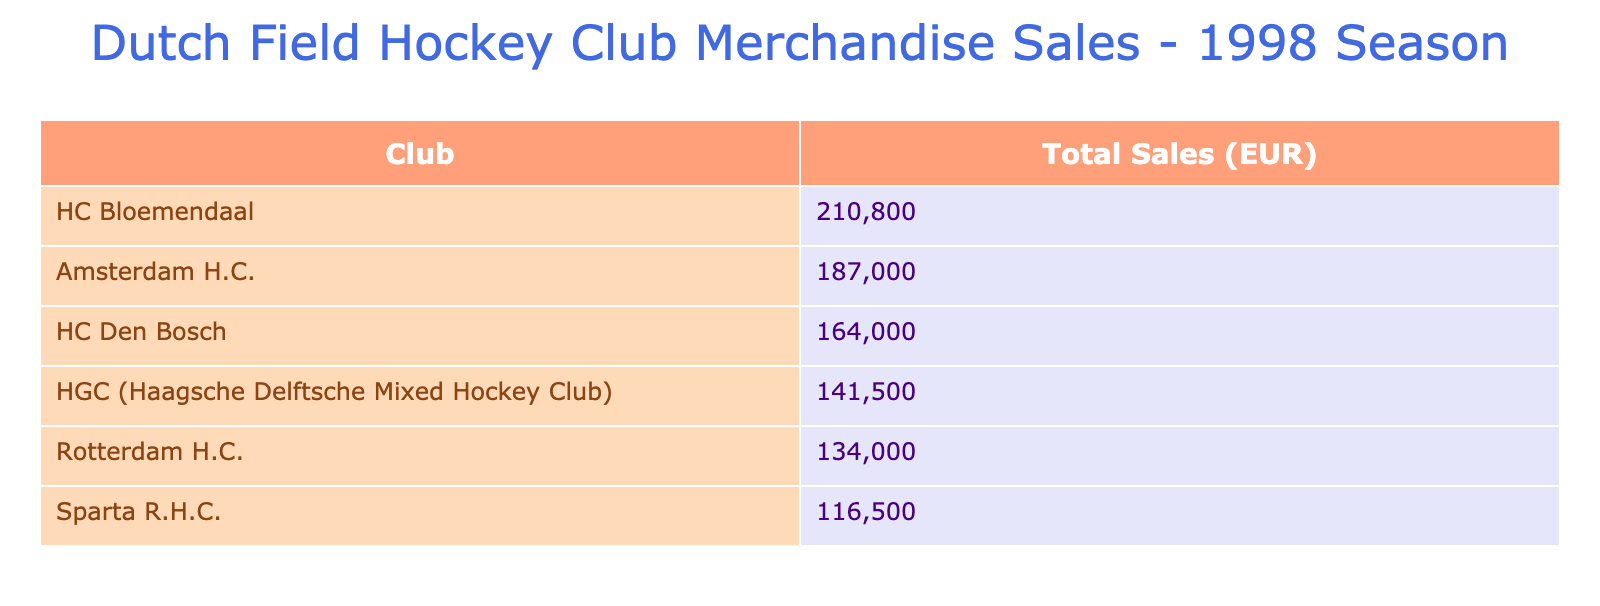What Dutch field hockey club had the highest total merchandise sales in 1998? By examining the table, we can see the total sales figures listed next to each club. On comparing these values, Amsterdam H.C. has the highest total sales of 160,000 EUR.
Answer: Amsterdam H.C How many units of accessories did HC Bloemendaal sell in total? Within the table, we see that HC Bloemendaal sold 2100 socks and 2000 water bottles as accessories. Adding these figures together gives a total of 4100 units sold.
Answer: 4100 Is it true that HGC sold more hats than scarves in 1998? The table shows HGC sold 1400 hats and 1500 scarves. Since 1400 is less than 1500, the statement is false.
Answer: No What was the average total sales per club for the clubs listed? First, we total the sales: 160,000 + 105,000 + 168,800 + 143,000 + 92,500 + 60,000 = 829,300 EUR. Since there are 6 clubs, dividing the total sales by 6 gives us an average of 138,216.67 EUR.
Answer: 138,216.67 EUR Which club sold the least number of accessories overall, and how much did they sell? By looking at the accessories sales for each club, we see the lowest total comes from Sparta R.H.C. with 11,500 EUR (1100 scarves and 1000 hats) in total.
Answer: Sparta R.H.C., 11,500 EUR 